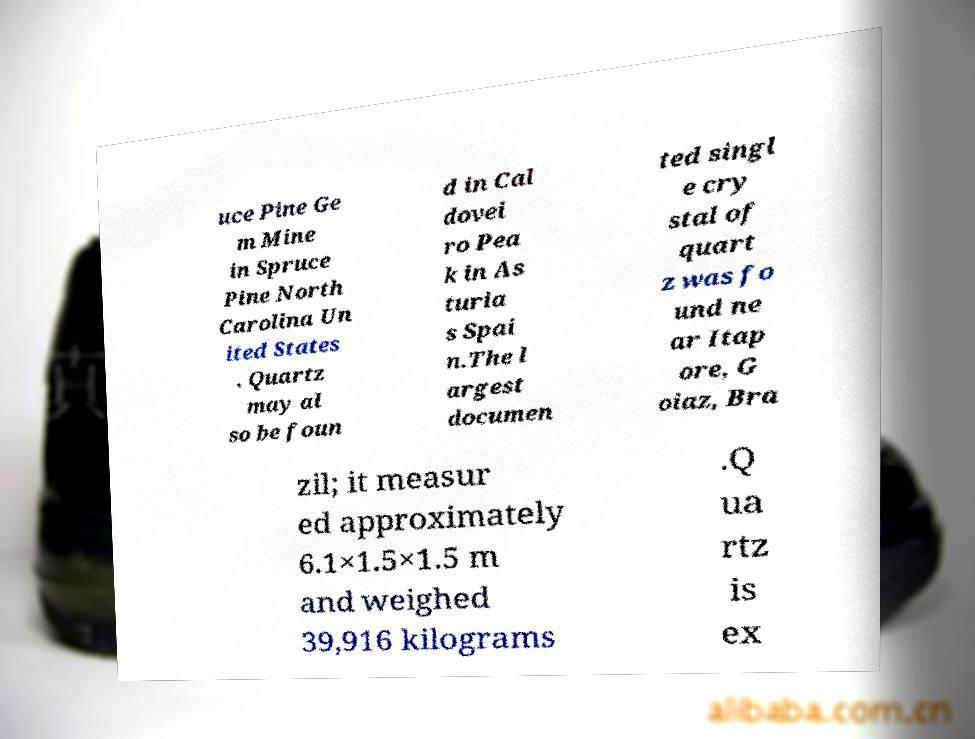What messages or text are displayed in this image? I need them in a readable, typed format. uce Pine Ge m Mine in Spruce Pine North Carolina Un ited States . Quartz may al so be foun d in Cal dovei ro Pea k in As turia s Spai n.The l argest documen ted singl e cry stal of quart z was fo und ne ar Itap ore, G oiaz, Bra zil; it measur ed approximately 6.1×1.5×1.5 m and weighed 39,916 kilograms .Q ua rtz is ex 